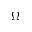<formula> <loc_0><loc_0><loc_500><loc_500>\Omega</formula> 